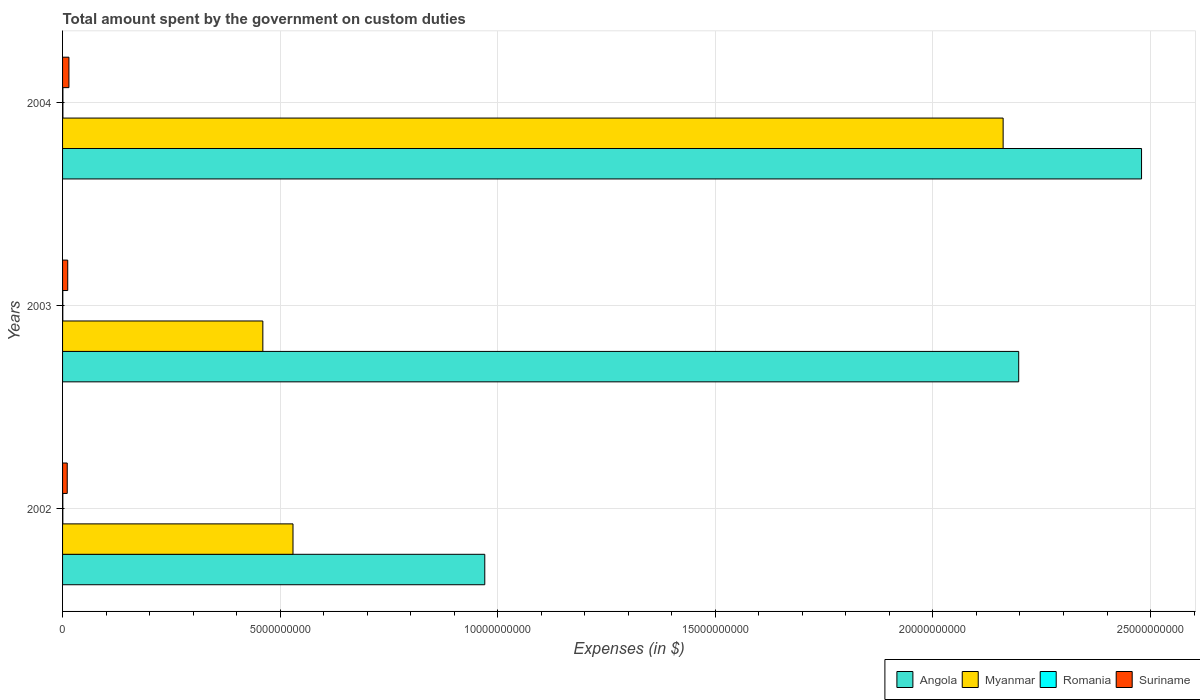How many different coloured bars are there?
Your answer should be compact. 4. How many groups of bars are there?
Ensure brevity in your answer.  3. Are the number of bars per tick equal to the number of legend labels?
Keep it short and to the point. Yes. Are the number of bars on each tick of the Y-axis equal?
Provide a succinct answer. Yes. What is the label of the 2nd group of bars from the top?
Keep it short and to the point. 2003. In how many cases, is the number of bars for a given year not equal to the number of legend labels?
Ensure brevity in your answer.  0. What is the amount spent on custom duties by the government in Myanmar in 2004?
Provide a succinct answer. 2.16e+1. Across all years, what is the maximum amount spent on custom duties by the government in Angola?
Provide a short and direct response. 2.48e+1. Across all years, what is the minimum amount spent on custom duties by the government in Romania?
Your answer should be compact. 5.31e+06. In which year was the amount spent on custom duties by the government in Angola maximum?
Provide a succinct answer. 2004. In which year was the amount spent on custom duties by the government in Suriname minimum?
Your answer should be compact. 2002. What is the total amount spent on custom duties by the government in Romania in the graph?
Give a very brief answer. 1.92e+07. What is the difference between the amount spent on custom duties by the government in Romania in 2003 and that in 2004?
Give a very brief answer. -2.61e+06. What is the difference between the amount spent on custom duties by the government in Angola in 2004 and the amount spent on custom duties by the government in Myanmar in 2003?
Ensure brevity in your answer.  2.02e+1. What is the average amount spent on custom duties by the government in Angola per year?
Make the answer very short. 1.88e+1. In the year 2002, what is the difference between the amount spent on custom duties by the government in Romania and amount spent on custom duties by the government in Suriname?
Provide a succinct answer. -1.01e+08. What is the ratio of the amount spent on custom duties by the government in Romania in 2002 to that in 2003?
Offer a very short reply. 1.12. Is the amount spent on custom duties by the government in Suriname in 2002 less than that in 2003?
Provide a succinct answer. Yes. Is the difference between the amount spent on custom duties by the government in Romania in 2003 and 2004 greater than the difference between the amount spent on custom duties by the government in Suriname in 2003 and 2004?
Offer a terse response. Yes. What is the difference between the highest and the second highest amount spent on custom duties by the government in Myanmar?
Keep it short and to the point. 1.63e+1. What is the difference between the highest and the lowest amount spent on custom duties by the government in Myanmar?
Your response must be concise. 1.70e+1. In how many years, is the amount spent on custom duties by the government in Suriname greater than the average amount spent on custom duties by the government in Suriname taken over all years?
Keep it short and to the point. 1. Is the sum of the amount spent on custom duties by the government in Myanmar in 2002 and 2004 greater than the maximum amount spent on custom duties by the government in Angola across all years?
Offer a very short reply. Yes. What does the 1st bar from the top in 2003 represents?
Your response must be concise. Suriname. What does the 3rd bar from the bottom in 2003 represents?
Give a very brief answer. Romania. Is it the case that in every year, the sum of the amount spent on custom duties by the government in Romania and amount spent on custom duties by the government in Myanmar is greater than the amount spent on custom duties by the government in Suriname?
Offer a very short reply. Yes. How many bars are there?
Give a very brief answer. 12. How many years are there in the graph?
Your answer should be very brief. 3. Are the values on the major ticks of X-axis written in scientific E-notation?
Your answer should be very brief. No. Does the graph contain any zero values?
Your answer should be compact. No. Does the graph contain grids?
Your answer should be very brief. Yes. Where does the legend appear in the graph?
Give a very brief answer. Bottom right. How many legend labels are there?
Offer a terse response. 4. How are the legend labels stacked?
Offer a terse response. Horizontal. What is the title of the graph?
Give a very brief answer. Total amount spent by the government on custom duties. What is the label or title of the X-axis?
Ensure brevity in your answer.  Expenses (in $). What is the label or title of the Y-axis?
Offer a terse response. Years. What is the Expenses (in $) in Angola in 2002?
Provide a succinct answer. 9.70e+09. What is the Expenses (in $) of Myanmar in 2002?
Offer a terse response. 5.30e+09. What is the Expenses (in $) of Romania in 2002?
Your response must be concise. 5.97e+06. What is the Expenses (in $) of Suriname in 2002?
Provide a succinct answer. 1.07e+08. What is the Expenses (in $) in Angola in 2003?
Your answer should be very brief. 2.20e+1. What is the Expenses (in $) of Myanmar in 2003?
Give a very brief answer. 4.60e+09. What is the Expenses (in $) in Romania in 2003?
Your answer should be compact. 5.31e+06. What is the Expenses (in $) in Suriname in 2003?
Make the answer very short. 1.19e+08. What is the Expenses (in $) in Angola in 2004?
Make the answer very short. 2.48e+1. What is the Expenses (in $) of Myanmar in 2004?
Ensure brevity in your answer.  2.16e+1. What is the Expenses (in $) of Romania in 2004?
Your response must be concise. 7.91e+06. What is the Expenses (in $) of Suriname in 2004?
Provide a succinct answer. 1.46e+08. Across all years, what is the maximum Expenses (in $) in Angola?
Give a very brief answer. 2.48e+1. Across all years, what is the maximum Expenses (in $) in Myanmar?
Your answer should be very brief. 2.16e+1. Across all years, what is the maximum Expenses (in $) in Romania?
Ensure brevity in your answer.  7.91e+06. Across all years, what is the maximum Expenses (in $) in Suriname?
Make the answer very short. 1.46e+08. Across all years, what is the minimum Expenses (in $) in Angola?
Make the answer very short. 9.70e+09. Across all years, what is the minimum Expenses (in $) in Myanmar?
Provide a succinct answer. 4.60e+09. Across all years, what is the minimum Expenses (in $) in Romania?
Provide a succinct answer. 5.31e+06. Across all years, what is the minimum Expenses (in $) in Suriname?
Your answer should be very brief. 1.07e+08. What is the total Expenses (in $) of Angola in the graph?
Offer a terse response. 5.65e+1. What is the total Expenses (in $) of Myanmar in the graph?
Offer a terse response. 3.15e+1. What is the total Expenses (in $) in Romania in the graph?
Offer a very short reply. 1.92e+07. What is the total Expenses (in $) in Suriname in the graph?
Provide a short and direct response. 3.72e+08. What is the difference between the Expenses (in $) in Angola in 2002 and that in 2003?
Make the answer very short. -1.23e+1. What is the difference between the Expenses (in $) in Myanmar in 2002 and that in 2003?
Ensure brevity in your answer.  6.93e+08. What is the difference between the Expenses (in $) in Romania in 2002 and that in 2003?
Give a very brief answer. 6.60e+05. What is the difference between the Expenses (in $) of Suriname in 2002 and that in 2003?
Give a very brief answer. -1.16e+07. What is the difference between the Expenses (in $) of Angola in 2002 and that in 2004?
Your answer should be compact. -1.51e+1. What is the difference between the Expenses (in $) of Myanmar in 2002 and that in 2004?
Keep it short and to the point. -1.63e+1. What is the difference between the Expenses (in $) of Romania in 2002 and that in 2004?
Offer a terse response. -1.94e+06. What is the difference between the Expenses (in $) of Suriname in 2002 and that in 2004?
Provide a succinct answer. -3.92e+07. What is the difference between the Expenses (in $) in Angola in 2003 and that in 2004?
Your answer should be very brief. -2.82e+09. What is the difference between the Expenses (in $) of Myanmar in 2003 and that in 2004?
Give a very brief answer. -1.70e+1. What is the difference between the Expenses (in $) in Romania in 2003 and that in 2004?
Your answer should be very brief. -2.61e+06. What is the difference between the Expenses (in $) of Suriname in 2003 and that in 2004?
Ensure brevity in your answer.  -2.77e+07. What is the difference between the Expenses (in $) in Angola in 2002 and the Expenses (in $) in Myanmar in 2003?
Provide a succinct answer. 5.10e+09. What is the difference between the Expenses (in $) of Angola in 2002 and the Expenses (in $) of Romania in 2003?
Provide a short and direct response. 9.70e+09. What is the difference between the Expenses (in $) in Angola in 2002 and the Expenses (in $) in Suriname in 2003?
Provide a succinct answer. 9.58e+09. What is the difference between the Expenses (in $) in Myanmar in 2002 and the Expenses (in $) in Romania in 2003?
Offer a very short reply. 5.29e+09. What is the difference between the Expenses (in $) in Myanmar in 2002 and the Expenses (in $) in Suriname in 2003?
Offer a terse response. 5.18e+09. What is the difference between the Expenses (in $) in Romania in 2002 and the Expenses (in $) in Suriname in 2003?
Your answer should be compact. -1.13e+08. What is the difference between the Expenses (in $) in Angola in 2002 and the Expenses (in $) in Myanmar in 2004?
Ensure brevity in your answer.  -1.19e+1. What is the difference between the Expenses (in $) of Angola in 2002 and the Expenses (in $) of Romania in 2004?
Your answer should be very brief. 9.69e+09. What is the difference between the Expenses (in $) in Angola in 2002 and the Expenses (in $) in Suriname in 2004?
Ensure brevity in your answer.  9.56e+09. What is the difference between the Expenses (in $) of Myanmar in 2002 and the Expenses (in $) of Romania in 2004?
Make the answer very short. 5.29e+09. What is the difference between the Expenses (in $) of Myanmar in 2002 and the Expenses (in $) of Suriname in 2004?
Make the answer very short. 5.15e+09. What is the difference between the Expenses (in $) of Romania in 2002 and the Expenses (in $) of Suriname in 2004?
Offer a terse response. -1.40e+08. What is the difference between the Expenses (in $) in Angola in 2003 and the Expenses (in $) in Myanmar in 2004?
Make the answer very short. 3.58e+08. What is the difference between the Expenses (in $) in Angola in 2003 and the Expenses (in $) in Romania in 2004?
Your answer should be compact. 2.20e+1. What is the difference between the Expenses (in $) in Angola in 2003 and the Expenses (in $) in Suriname in 2004?
Give a very brief answer. 2.18e+1. What is the difference between the Expenses (in $) in Myanmar in 2003 and the Expenses (in $) in Romania in 2004?
Keep it short and to the point. 4.59e+09. What is the difference between the Expenses (in $) in Myanmar in 2003 and the Expenses (in $) in Suriname in 2004?
Your answer should be very brief. 4.46e+09. What is the difference between the Expenses (in $) in Romania in 2003 and the Expenses (in $) in Suriname in 2004?
Ensure brevity in your answer.  -1.41e+08. What is the average Expenses (in $) in Angola per year?
Your answer should be compact. 1.88e+1. What is the average Expenses (in $) of Myanmar per year?
Provide a short and direct response. 1.05e+1. What is the average Expenses (in $) of Romania per year?
Keep it short and to the point. 6.40e+06. What is the average Expenses (in $) of Suriname per year?
Provide a succinct answer. 1.24e+08. In the year 2002, what is the difference between the Expenses (in $) of Angola and Expenses (in $) of Myanmar?
Give a very brief answer. 4.41e+09. In the year 2002, what is the difference between the Expenses (in $) in Angola and Expenses (in $) in Romania?
Provide a short and direct response. 9.70e+09. In the year 2002, what is the difference between the Expenses (in $) in Angola and Expenses (in $) in Suriname?
Offer a very short reply. 9.59e+09. In the year 2002, what is the difference between the Expenses (in $) of Myanmar and Expenses (in $) of Romania?
Give a very brief answer. 5.29e+09. In the year 2002, what is the difference between the Expenses (in $) of Myanmar and Expenses (in $) of Suriname?
Offer a very short reply. 5.19e+09. In the year 2002, what is the difference between the Expenses (in $) in Romania and Expenses (in $) in Suriname?
Offer a very short reply. -1.01e+08. In the year 2003, what is the difference between the Expenses (in $) of Angola and Expenses (in $) of Myanmar?
Offer a terse response. 1.74e+1. In the year 2003, what is the difference between the Expenses (in $) of Angola and Expenses (in $) of Romania?
Offer a terse response. 2.20e+1. In the year 2003, what is the difference between the Expenses (in $) in Angola and Expenses (in $) in Suriname?
Ensure brevity in your answer.  2.19e+1. In the year 2003, what is the difference between the Expenses (in $) in Myanmar and Expenses (in $) in Romania?
Offer a very short reply. 4.60e+09. In the year 2003, what is the difference between the Expenses (in $) in Myanmar and Expenses (in $) in Suriname?
Give a very brief answer. 4.48e+09. In the year 2003, what is the difference between the Expenses (in $) of Romania and Expenses (in $) of Suriname?
Your answer should be compact. -1.13e+08. In the year 2004, what is the difference between the Expenses (in $) in Angola and Expenses (in $) in Myanmar?
Make the answer very short. 3.18e+09. In the year 2004, what is the difference between the Expenses (in $) of Angola and Expenses (in $) of Romania?
Your answer should be very brief. 2.48e+1. In the year 2004, what is the difference between the Expenses (in $) of Angola and Expenses (in $) of Suriname?
Provide a short and direct response. 2.46e+1. In the year 2004, what is the difference between the Expenses (in $) of Myanmar and Expenses (in $) of Romania?
Your answer should be compact. 2.16e+1. In the year 2004, what is the difference between the Expenses (in $) in Myanmar and Expenses (in $) in Suriname?
Your answer should be very brief. 2.15e+1. In the year 2004, what is the difference between the Expenses (in $) in Romania and Expenses (in $) in Suriname?
Your answer should be compact. -1.38e+08. What is the ratio of the Expenses (in $) of Angola in 2002 to that in 2003?
Provide a succinct answer. 0.44. What is the ratio of the Expenses (in $) in Myanmar in 2002 to that in 2003?
Your answer should be compact. 1.15. What is the ratio of the Expenses (in $) in Romania in 2002 to that in 2003?
Give a very brief answer. 1.12. What is the ratio of the Expenses (in $) in Suriname in 2002 to that in 2003?
Your response must be concise. 0.9. What is the ratio of the Expenses (in $) of Angola in 2002 to that in 2004?
Your answer should be very brief. 0.39. What is the ratio of the Expenses (in $) in Myanmar in 2002 to that in 2004?
Ensure brevity in your answer.  0.24. What is the ratio of the Expenses (in $) in Romania in 2002 to that in 2004?
Your answer should be compact. 0.75. What is the ratio of the Expenses (in $) in Suriname in 2002 to that in 2004?
Give a very brief answer. 0.73. What is the ratio of the Expenses (in $) of Angola in 2003 to that in 2004?
Provide a short and direct response. 0.89. What is the ratio of the Expenses (in $) of Myanmar in 2003 to that in 2004?
Provide a short and direct response. 0.21. What is the ratio of the Expenses (in $) of Romania in 2003 to that in 2004?
Your answer should be very brief. 0.67. What is the ratio of the Expenses (in $) of Suriname in 2003 to that in 2004?
Keep it short and to the point. 0.81. What is the difference between the highest and the second highest Expenses (in $) in Angola?
Provide a short and direct response. 2.82e+09. What is the difference between the highest and the second highest Expenses (in $) of Myanmar?
Your response must be concise. 1.63e+1. What is the difference between the highest and the second highest Expenses (in $) of Romania?
Provide a succinct answer. 1.94e+06. What is the difference between the highest and the second highest Expenses (in $) in Suriname?
Make the answer very short. 2.77e+07. What is the difference between the highest and the lowest Expenses (in $) of Angola?
Provide a succinct answer. 1.51e+1. What is the difference between the highest and the lowest Expenses (in $) in Myanmar?
Your answer should be very brief. 1.70e+1. What is the difference between the highest and the lowest Expenses (in $) in Romania?
Provide a succinct answer. 2.61e+06. What is the difference between the highest and the lowest Expenses (in $) of Suriname?
Your answer should be compact. 3.92e+07. 